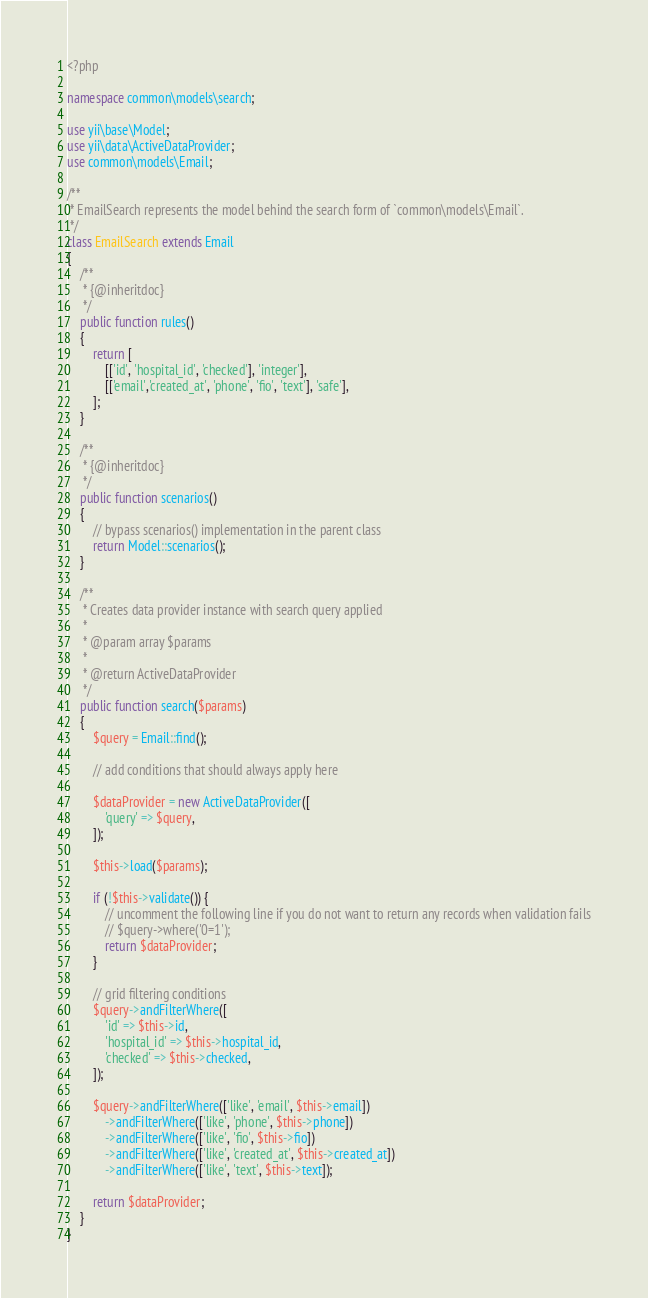Convert code to text. <code><loc_0><loc_0><loc_500><loc_500><_PHP_><?php

namespace common\models\search;

use yii\base\Model;
use yii\data\ActiveDataProvider;
use common\models\Email;

/**
 * EmailSearch represents the model behind the search form of `common\models\Email`.
 */
class EmailSearch extends Email
{
    /**
     * {@inheritdoc}
     */
    public function rules()
    {
        return [
            [['id', 'hospital_id', 'checked'], 'integer'],
            [['email','created_at', 'phone', 'fio', 'text'], 'safe'],
        ];
    }

    /**
     * {@inheritdoc}
     */
    public function scenarios()
    {
        // bypass scenarios() implementation in the parent class
        return Model::scenarios();
    }

    /**
     * Creates data provider instance with search query applied
     *
     * @param array $params
     *
     * @return ActiveDataProvider
     */
    public function search($params)
    {
        $query = Email::find();

        // add conditions that should always apply here

        $dataProvider = new ActiveDataProvider([
            'query' => $query,
        ]);

        $this->load($params);

        if (!$this->validate()) {
            // uncomment the following line if you do not want to return any records when validation fails
            // $query->where('0=1');
            return $dataProvider;
        }

        // grid filtering conditions
        $query->andFilterWhere([
            'id' => $this->id,
            'hospital_id' => $this->hospital_id,
            'checked' => $this->checked,
        ]);

        $query->andFilterWhere(['like', 'email', $this->email])
            ->andFilterWhere(['like', 'phone', $this->phone])
            ->andFilterWhere(['like', 'fio', $this->fio])
            ->andFilterWhere(['like', 'created_at', $this->created_at])
            ->andFilterWhere(['like', 'text', $this->text]);

        return $dataProvider;
    }
}
</code> 